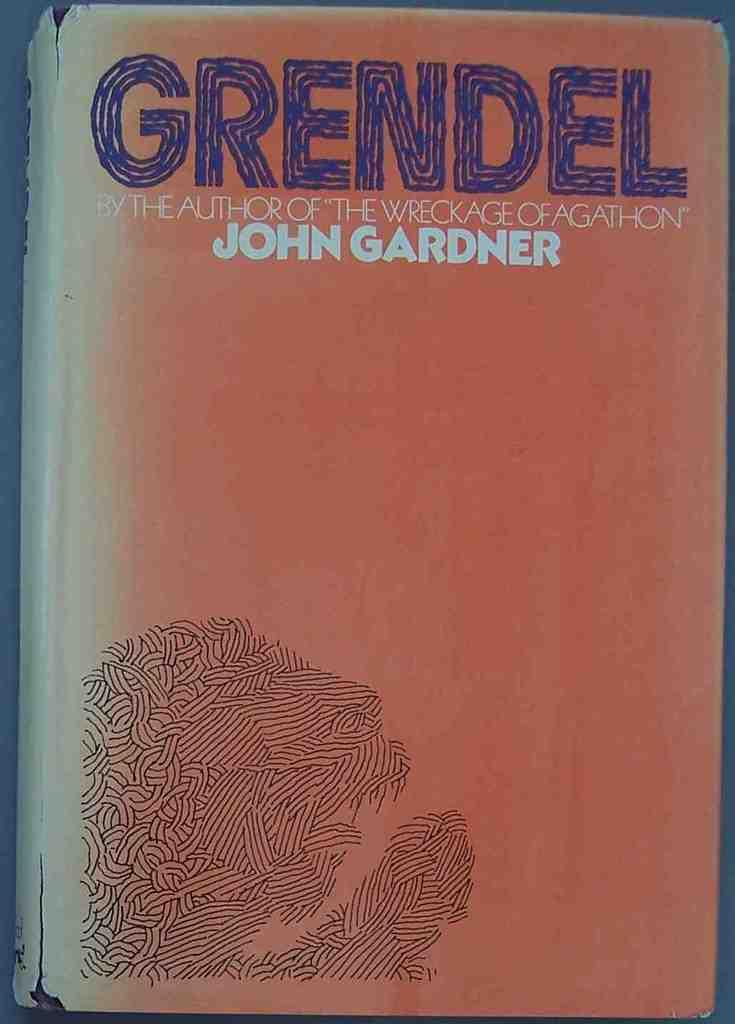<image>
Present a compact description of the photo's key features. worn copy of book grendel by john gardner 